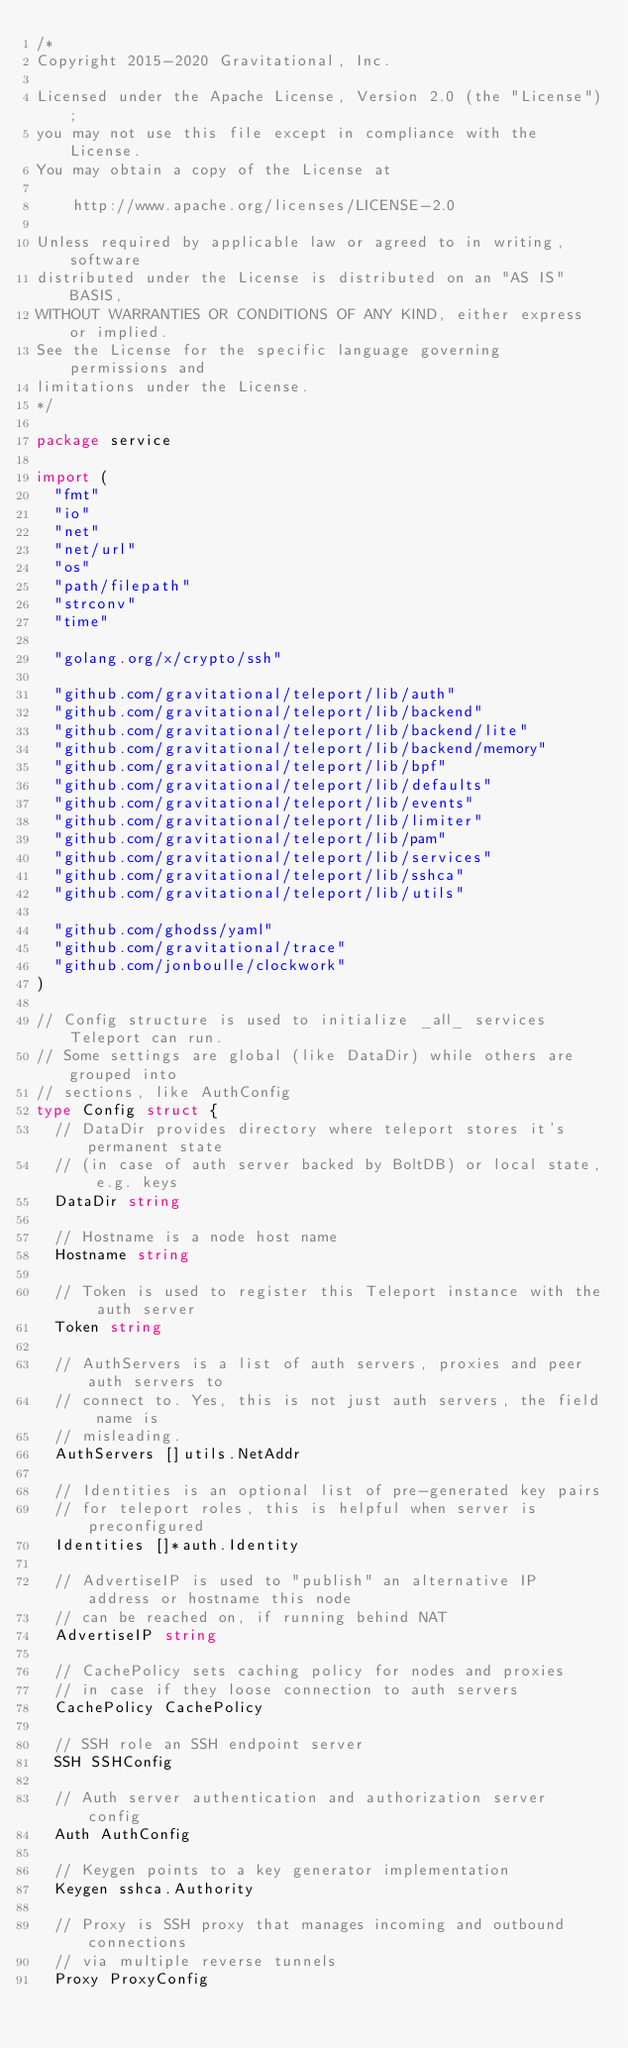<code> <loc_0><loc_0><loc_500><loc_500><_Go_>/*
Copyright 2015-2020 Gravitational, Inc.

Licensed under the Apache License, Version 2.0 (the "License");
you may not use this file except in compliance with the License.
You may obtain a copy of the License at

    http://www.apache.org/licenses/LICENSE-2.0

Unless required by applicable law or agreed to in writing, software
distributed under the License is distributed on an "AS IS" BASIS,
WITHOUT WARRANTIES OR CONDITIONS OF ANY KIND, either express or implied.
See the License for the specific language governing permissions and
limitations under the License.
*/

package service

import (
	"fmt"
	"io"
	"net"
	"net/url"
	"os"
	"path/filepath"
	"strconv"
	"time"

	"golang.org/x/crypto/ssh"

	"github.com/gravitational/teleport/lib/auth"
	"github.com/gravitational/teleport/lib/backend"
	"github.com/gravitational/teleport/lib/backend/lite"
	"github.com/gravitational/teleport/lib/backend/memory"
	"github.com/gravitational/teleport/lib/bpf"
	"github.com/gravitational/teleport/lib/defaults"
	"github.com/gravitational/teleport/lib/events"
	"github.com/gravitational/teleport/lib/limiter"
	"github.com/gravitational/teleport/lib/pam"
	"github.com/gravitational/teleport/lib/services"
	"github.com/gravitational/teleport/lib/sshca"
	"github.com/gravitational/teleport/lib/utils"

	"github.com/ghodss/yaml"
	"github.com/gravitational/trace"
	"github.com/jonboulle/clockwork"
)

// Config structure is used to initialize _all_ services Teleport can run.
// Some settings are global (like DataDir) while others are grouped into
// sections, like AuthConfig
type Config struct {
	// DataDir provides directory where teleport stores it's permanent state
	// (in case of auth server backed by BoltDB) or local state, e.g. keys
	DataDir string

	// Hostname is a node host name
	Hostname string

	// Token is used to register this Teleport instance with the auth server
	Token string

	// AuthServers is a list of auth servers, proxies and peer auth servers to
	// connect to. Yes, this is not just auth servers, the field name is
	// misleading.
	AuthServers []utils.NetAddr

	// Identities is an optional list of pre-generated key pairs
	// for teleport roles, this is helpful when server is preconfigured
	Identities []*auth.Identity

	// AdvertiseIP is used to "publish" an alternative IP address or hostname this node
	// can be reached on, if running behind NAT
	AdvertiseIP string

	// CachePolicy sets caching policy for nodes and proxies
	// in case if they loose connection to auth servers
	CachePolicy CachePolicy

	// SSH role an SSH endpoint server
	SSH SSHConfig

	// Auth server authentication and authorization server config
	Auth AuthConfig

	// Keygen points to a key generator implementation
	Keygen sshca.Authority

	// Proxy is SSH proxy that manages incoming and outbound connections
	// via multiple reverse tunnels
	Proxy ProxyConfig
</code> 